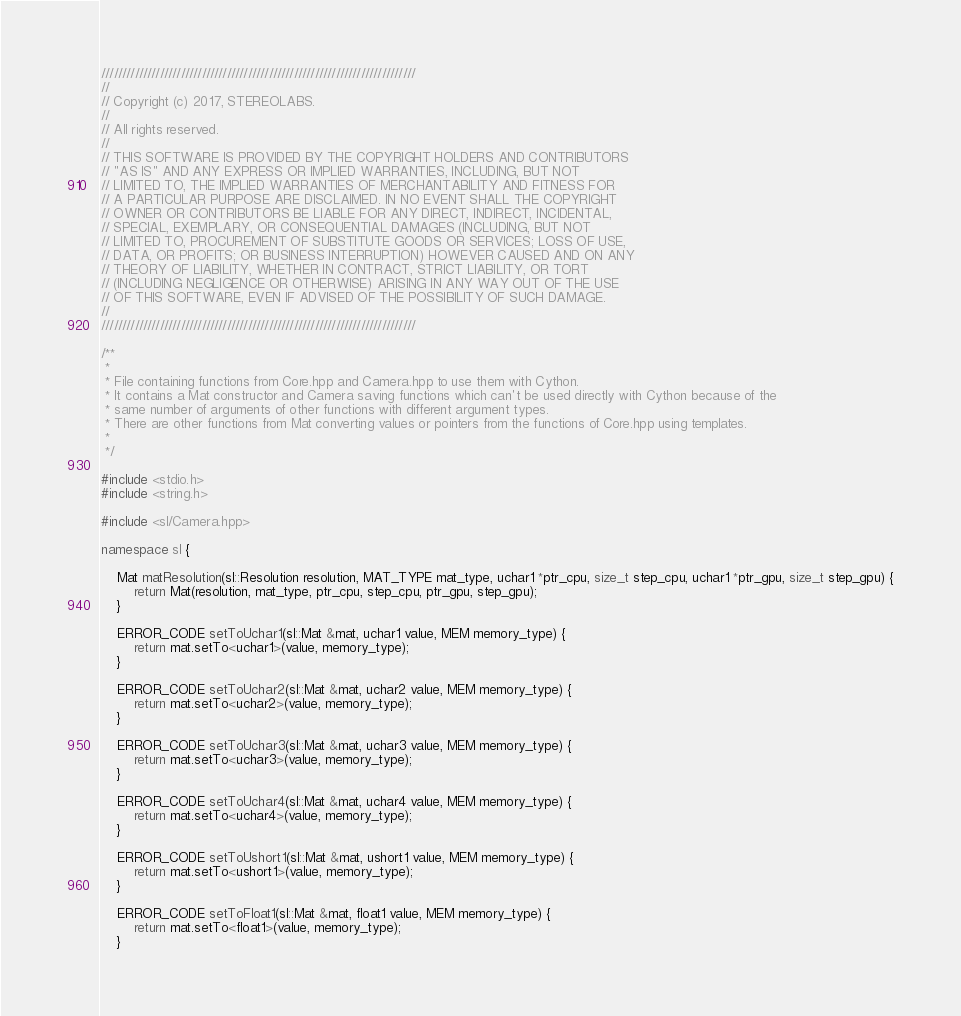<code> <loc_0><loc_0><loc_500><loc_500><_C++_>///////////////////////////////////////////////////////////////////////////
//
// Copyright (c) 2017, STEREOLABS.
//
// All rights reserved.
//
// THIS SOFTWARE IS PROVIDED BY THE COPYRIGHT HOLDERS AND CONTRIBUTORS
// "AS IS" AND ANY EXPRESS OR IMPLIED WARRANTIES, INCLUDING, BUT NOT
// LIMITED TO, THE IMPLIED WARRANTIES OF MERCHANTABILITY AND FITNESS FOR
// A PARTICULAR PURPOSE ARE DISCLAIMED. IN NO EVENT SHALL THE COPYRIGHT
// OWNER OR CONTRIBUTORS BE LIABLE FOR ANY DIRECT, INDIRECT, INCIDENTAL,
// SPECIAL, EXEMPLARY, OR CONSEQUENTIAL DAMAGES (INCLUDING, BUT NOT
// LIMITED TO, PROCUREMENT OF SUBSTITUTE GOODS OR SERVICES; LOSS OF USE,
// DATA, OR PROFITS; OR BUSINESS INTERRUPTION) HOWEVER CAUSED AND ON ANY
// THEORY OF LIABILITY, WHETHER IN CONTRACT, STRICT LIABILITY, OR TORT
// (INCLUDING NEGLIGENCE OR OTHERWISE) ARISING IN ANY WAY OUT OF THE USE
// OF THIS SOFTWARE, EVEN IF ADVISED OF THE POSSIBILITY OF SUCH DAMAGE.
//
///////////////////////////////////////////////////////////////////////////

/**
 *
 * File containing functions from Core.hpp and Camera.hpp to use them with Cython.
 * It contains a Mat constructor and Camera saving functions which can't be used directly with Cython because of the
 * same number of arguments of other functions with different argument types.
 * There are other functions from Mat converting values or pointers from the functions of Core.hpp using templates.
 *
 */

#include <stdio.h>
#include <string.h>

#include <sl/Camera.hpp>

namespace sl {

    Mat matResolution(sl::Resolution resolution, MAT_TYPE mat_type, uchar1 *ptr_cpu, size_t step_cpu, uchar1 *ptr_gpu, size_t step_gpu) {
        return Mat(resolution, mat_type, ptr_cpu, step_cpu, ptr_gpu, step_gpu);
    }

    ERROR_CODE setToUchar1(sl::Mat &mat, uchar1 value, MEM memory_type) {
        return mat.setTo<uchar1>(value, memory_type);
    }

    ERROR_CODE setToUchar2(sl::Mat &mat, uchar2 value, MEM memory_type) {
        return mat.setTo<uchar2>(value, memory_type);
    }

    ERROR_CODE setToUchar3(sl::Mat &mat, uchar3 value, MEM memory_type) {
        return mat.setTo<uchar3>(value, memory_type);
    }

    ERROR_CODE setToUchar4(sl::Mat &mat, uchar4 value, MEM memory_type) {
        return mat.setTo<uchar4>(value, memory_type);
    }

    ERROR_CODE setToUshort1(sl::Mat &mat, ushort1 value, MEM memory_type) {
        return mat.setTo<ushort1>(value, memory_type);
    }

    ERROR_CODE setToFloat1(sl::Mat &mat, float1 value, MEM memory_type) {
        return mat.setTo<float1>(value, memory_type);
    }
</code> 